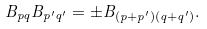Convert formula to latex. <formula><loc_0><loc_0><loc_500><loc_500>B _ { p q } B _ { p ^ { \prime } q ^ { \prime } } = \pm B _ { ( p + p ^ { \prime } ) ( q + q ^ { \prime } ) } .</formula> 